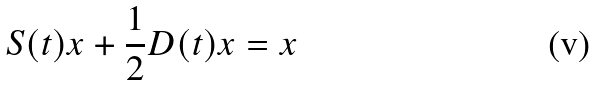Convert formula to latex. <formula><loc_0><loc_0><loc_500><loc_500>S ( t ) x + \frac { 1 } { 2 } D ( t ) x = x</formula> 